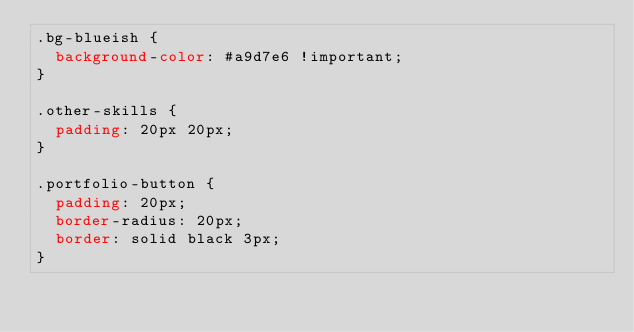<code> <loc_0><loc_0><loc_500><loc_500><_CSS_>.bg-blueish {
  background-color: #a9d7e6 !important;
}

.other-skills {
  padding: 20px 20px;
}

.portfolio-button {
  padding: 20px;
  border-radius: 20px;
  border: solid black 3px;
}</code> 